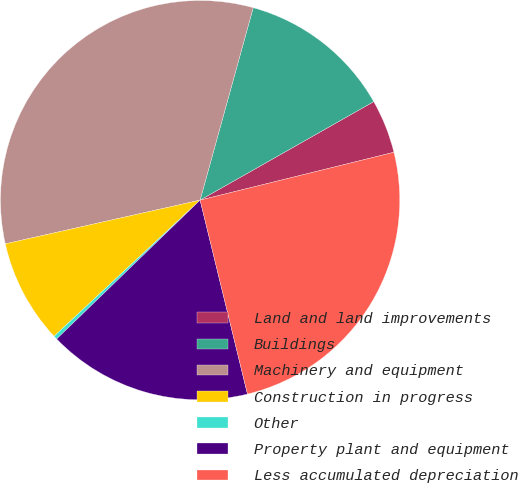Convert chart. <chart><loc_0><loc_0><loc_500><loc_500><pie_chart><fcel>Land and land improvements<fcel>Buildings<fcel>Machinery and equipment<fcel>Construction in progress<fcel>Other<fcel>Property plant and equipment<fcel>Less accumulated depreciation<nl><fcel>4.36%<fcel>12.5%<fcel>32.8%<fcel>8.43%<fcel>0.3%<fcel>16.57%<fcel>25.04%<nl></chart> 